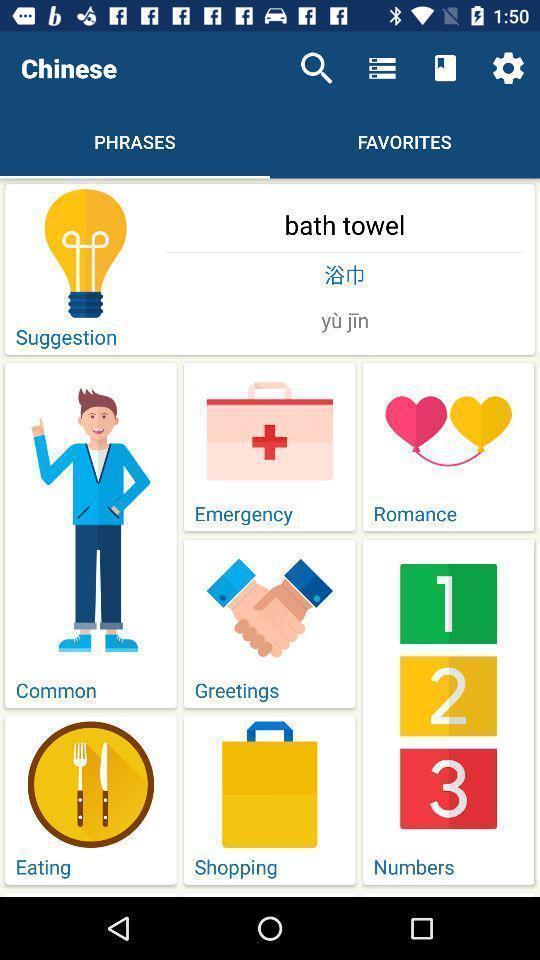Describe this image in words. Page displaying various categories in language learning application. 